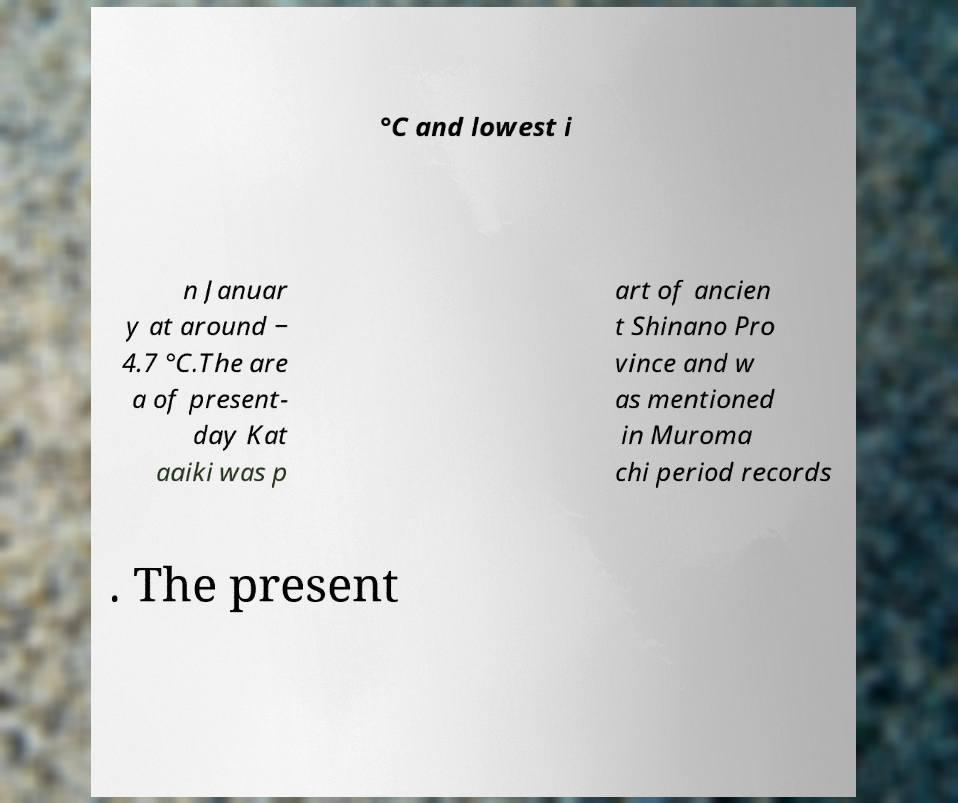Could you extract and type out the text from this image? °C and lowest i n Januar y at around − 4.7 °C.The are a of present- day Kat aaiki was p art of ancien t Shinano Pro vince and w as mentioned in Muroma chi period records . The present 